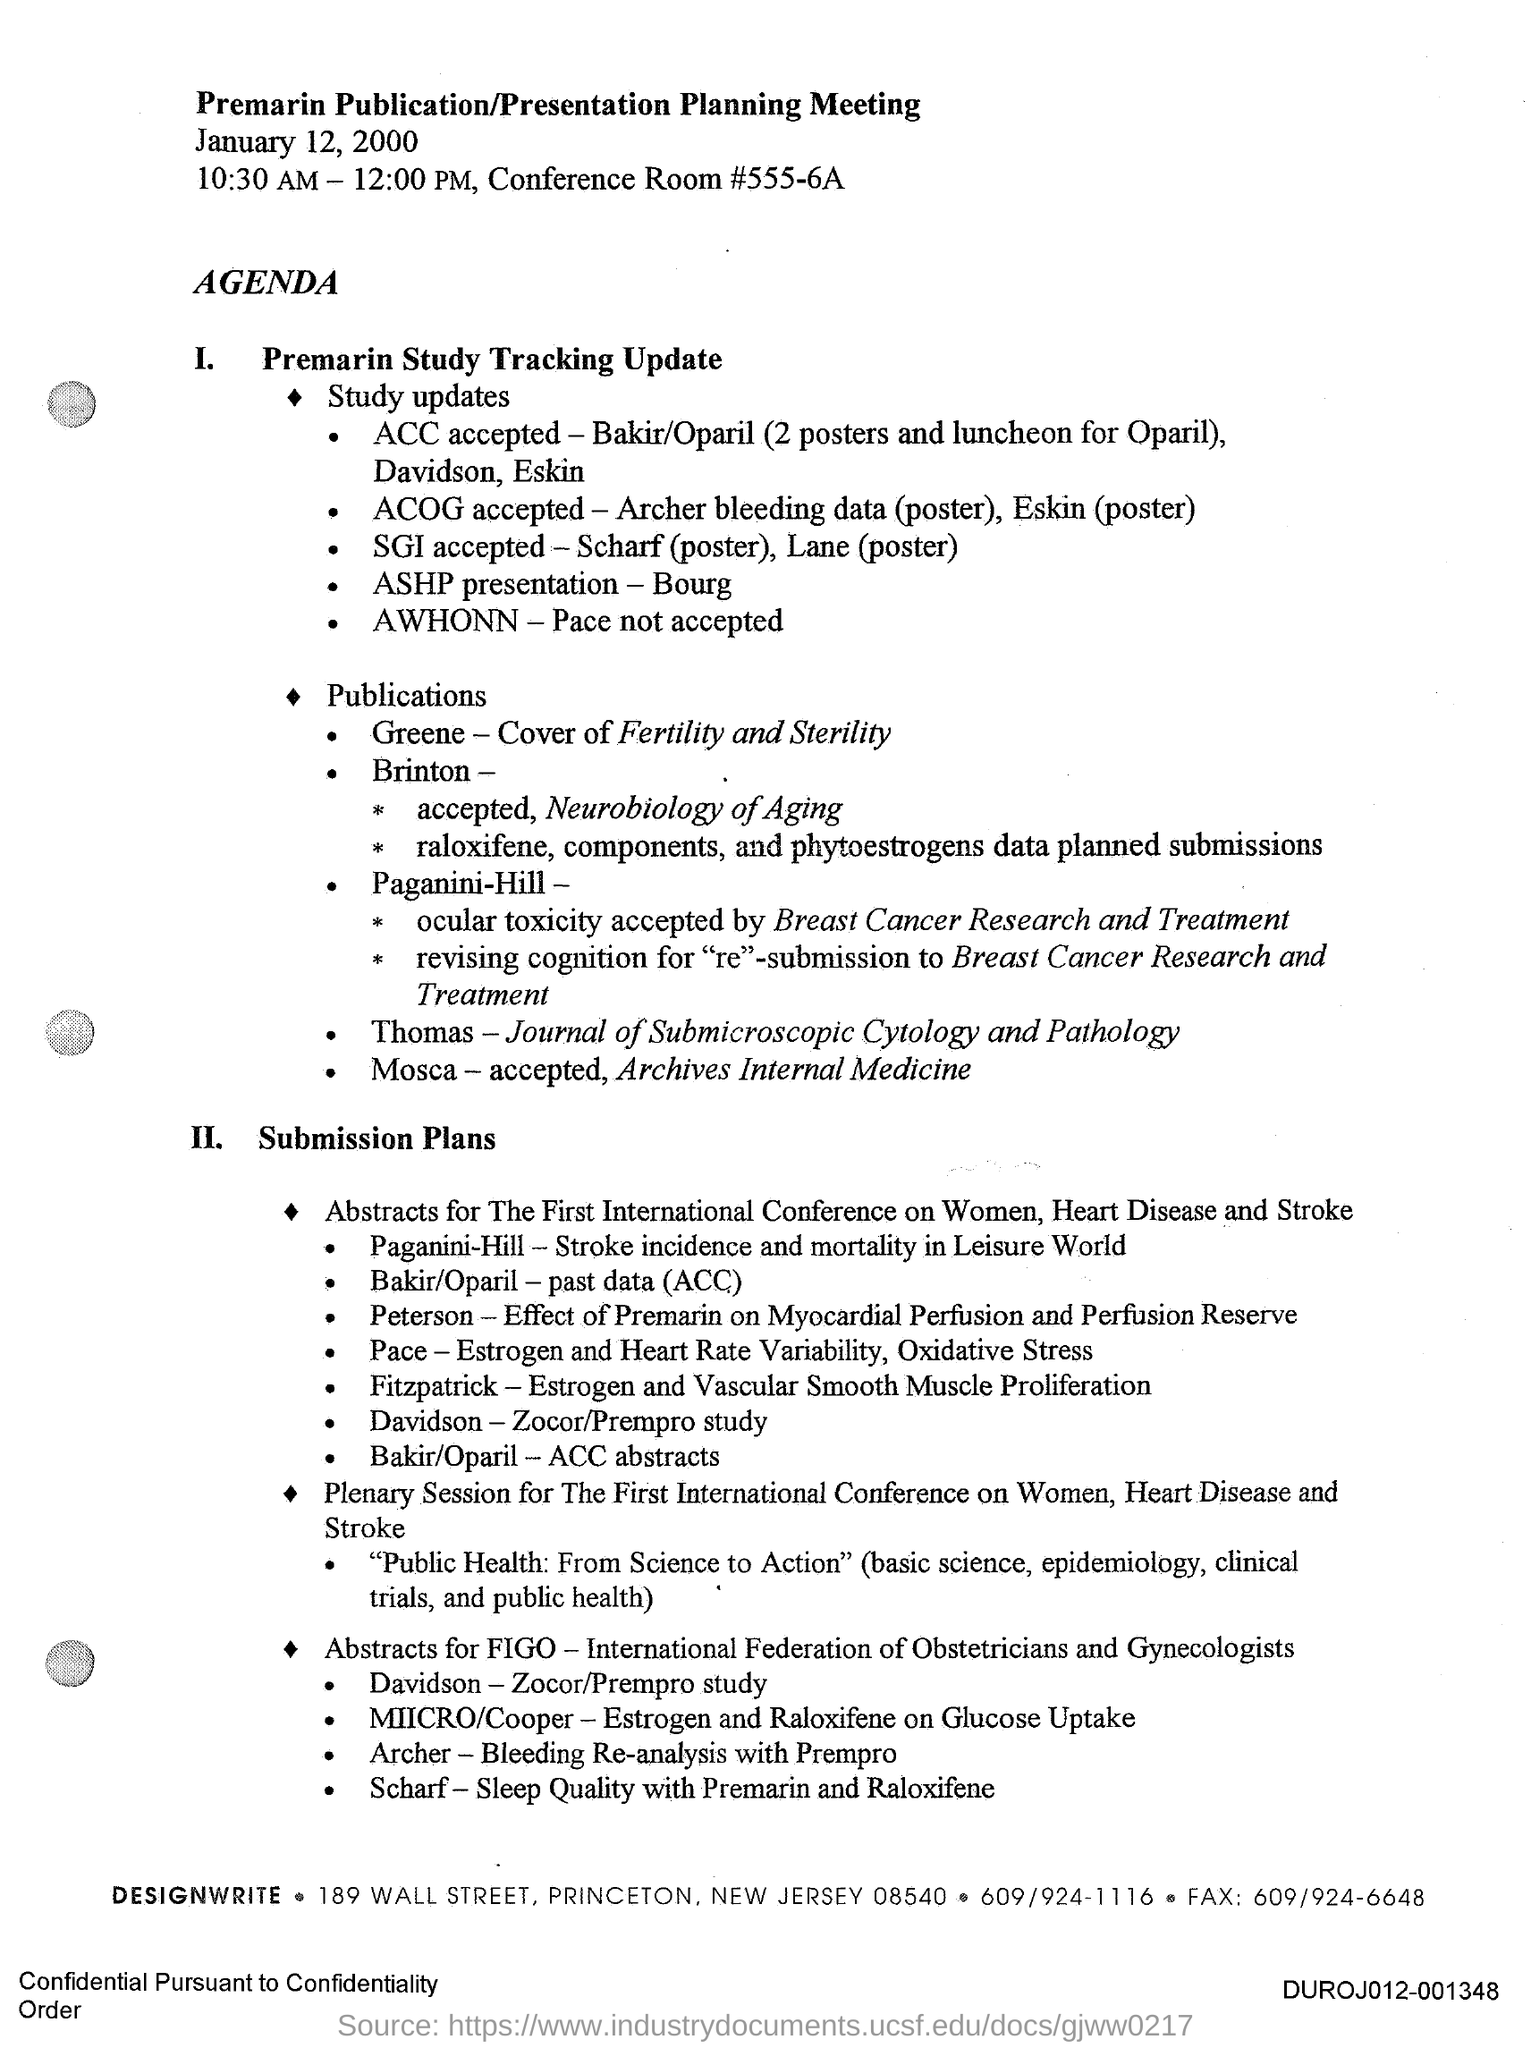What type of meeting is this ?
Your answer should be very brief. Premarin publication/presentation planning meeting. What is the date mentioned in the document ?
Ensure brevity in your answer.  January 12, 2000. What is the Conference Room Number ?
Keep it short and to the point. #555-6A. What is the Fax Number ?
Keep it short and to the point. 609/924-6648. 